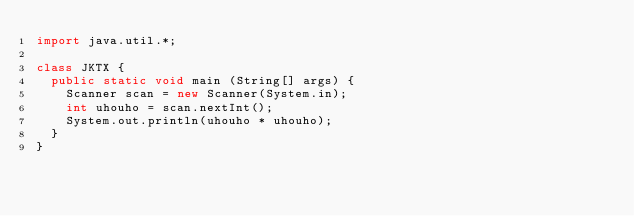<code> <loc_0><loc_0><loc_500><loc_500><_Java_>import java.util.*;

class JKTX {
	public static void main (String[] args) {
		Scanner scan = new Scanner(System.in);
		int uhouho = scan.nextInt();
		System.out.println(uhouho * uhouho);
	}
}</code> 